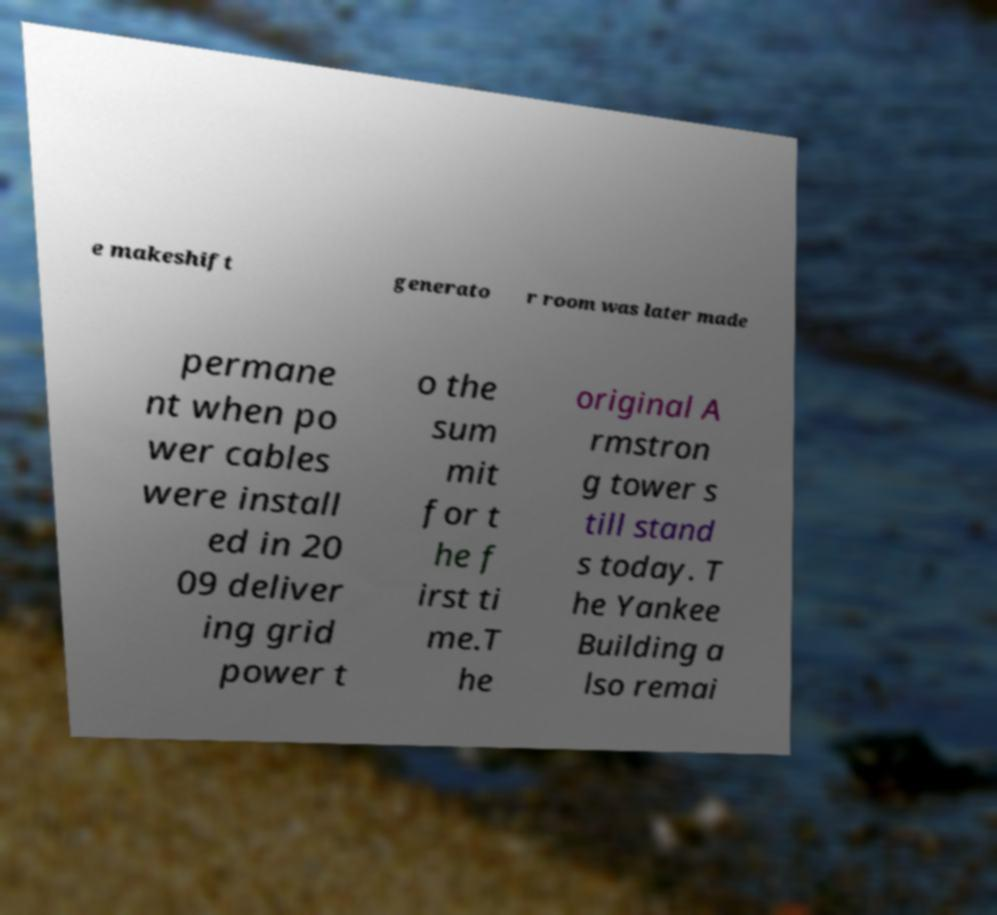Please read and relay the text visible in this image. What does it say? e makeshift generato r room was later made permane nt when po wer cables were install ed in 20 09 deliver ing grid power t o the sum mit for t he f irst ti me.T he original A rmstron g tower s till stand s today. T he Yankee Building a lso remai 